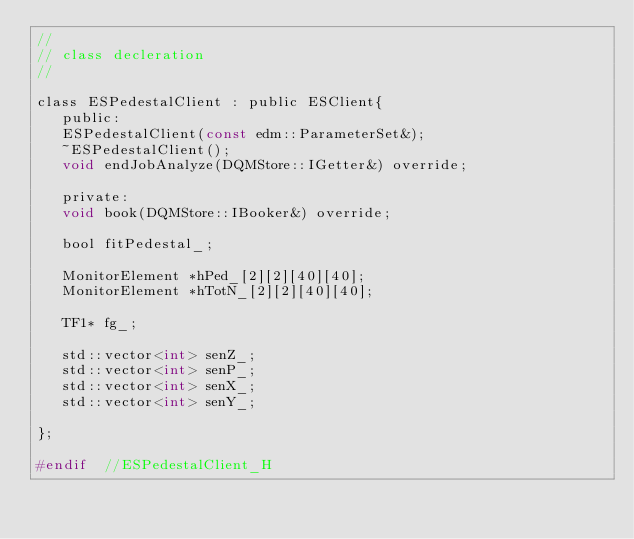Convert code to text. <code><loc_0><loc_0><loc_500><loc_500><_C_>//
// class decleration
//

class ESPedestalClient : public ESClient{
   public:
   ESPedestalClient(const edm::ParameterSet&);
   ~ESPedestalClient();
   void endJobAnalyze(DQMStore::IGetter&) override;

   private:
   void book(DQMStore::IBooker&) override;

   bool fitPedestal_;

   MonitorElement *hPed_[2][2][40][40];
   MonitorElement *hTotN_[2][2][40][40];

   TF1* fg_;

   std::vector<int> senZ_;
   std::vector<int> senP_;
   std::vector<int> senX_;
   std::vector<int> senY_;

};

#endif  //ESPedestalClient_H
</code> 